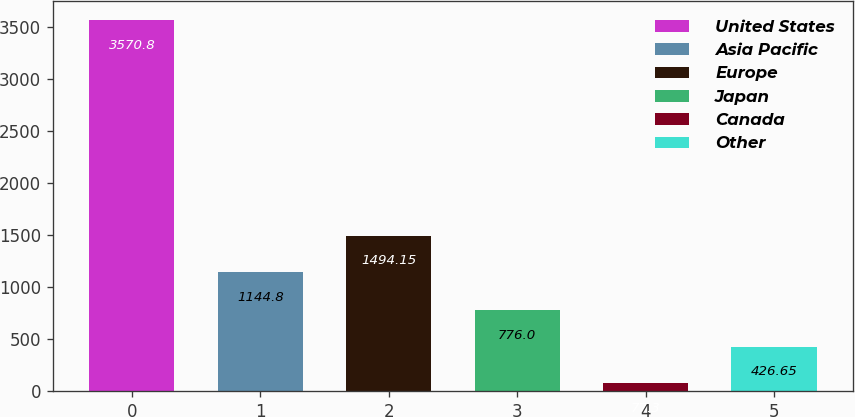Convert chart. <chart><loc_0><loc_0><loc_500><loc_500><bar_chart><fcel>United States<fcel>Asia Pacific<fcel>Europe<fcel>Japan<fcel>Canada<fcel>Other<nl><fcel>3570.8<fcel>1144.8<fcel>1494.15<fcel>776<fcel>77.3<fcel>426.65<nl></chart> 